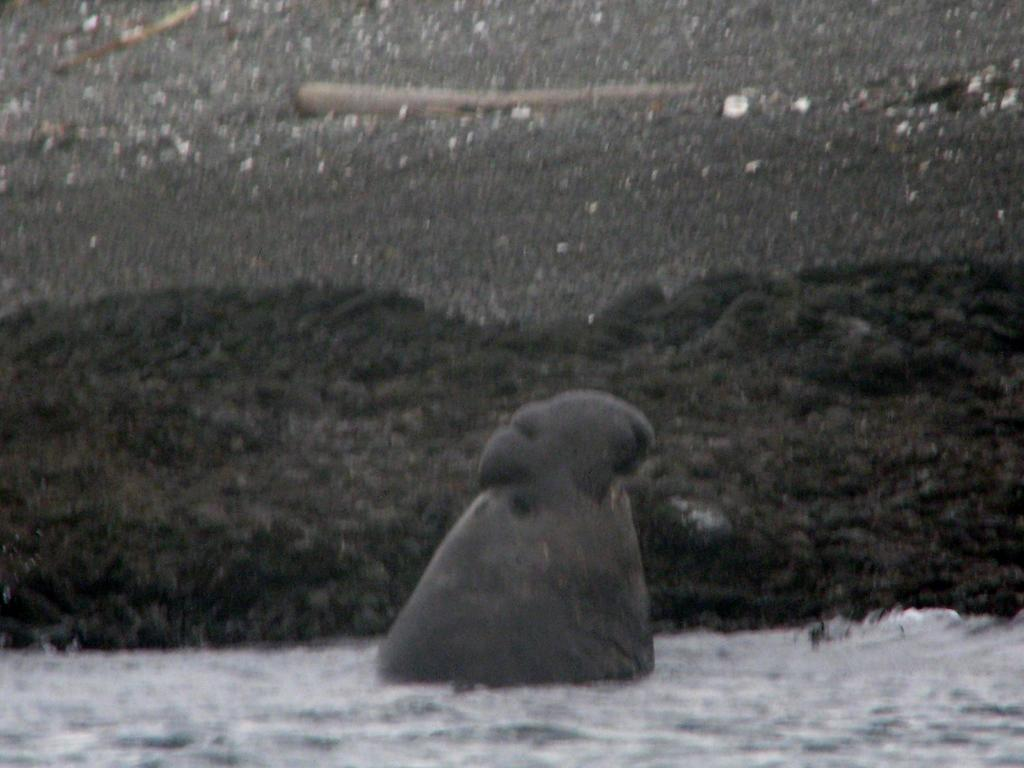What is the overall quality of the image? The image is blurry. What can be seen in the water in the image? There appears to be an object in the water. What type of terrain is visible in the background? There is sand visible in the background. What type of nail polish is the person wearing in the image? There is no person present in the image, and therefore no nail polish can be observed. 